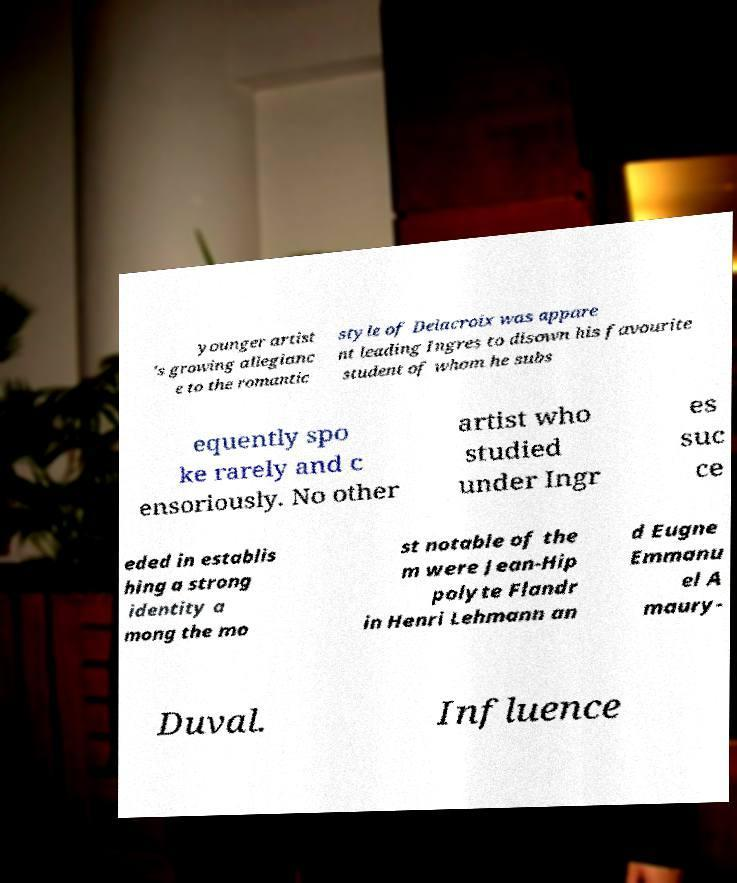There's text embedded in this image that I need extracted. Can you transcribe it verbatim? younger artist 's growing allegianc e to the romantic style of Delacroix was appare nt leading Ingres to disown his favourite student of whom he subs equently spo ke rarely and c ensoriously. No other artist who studied under Ingr es suc ce eded in establis hing a strong identity a mong the mo st notable of the m were Jean-Hip polyte Flandr in Henri Lehmann an d Eugne Emmanu el A maury- Duval. Influence 